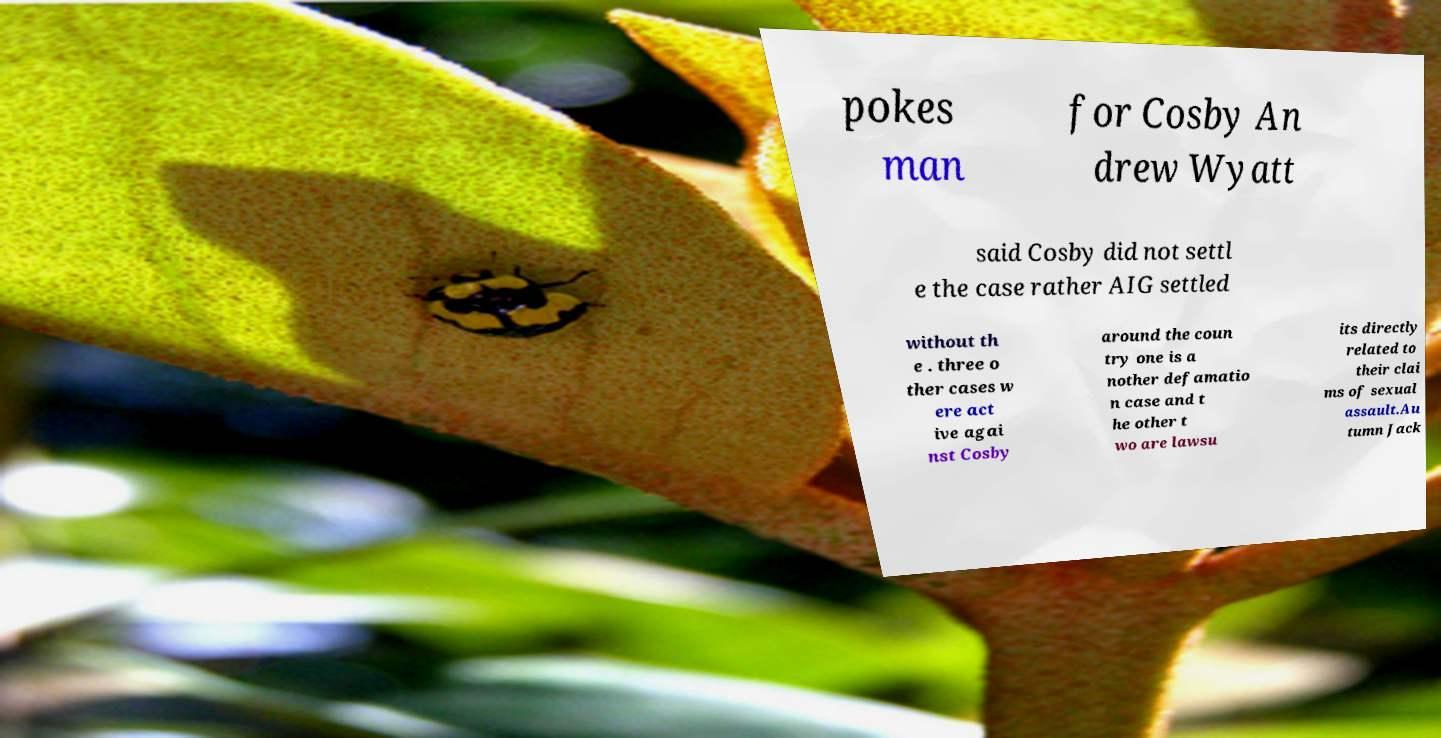Can you read and provide the text displayed in the image?This photo seems to have some interesting text. Can you extract and type it out for me? pokes man for Cosby An drew Wyatt said Cosby did not settl e the case rather AIG settled without th e . three o ther cases w ere act ive agai nst Cosby around the coun try one is a nother defamatio n case and t he other t wo are lawsu its directly related to their clai ms of sexual assault.Au tumn Jack 